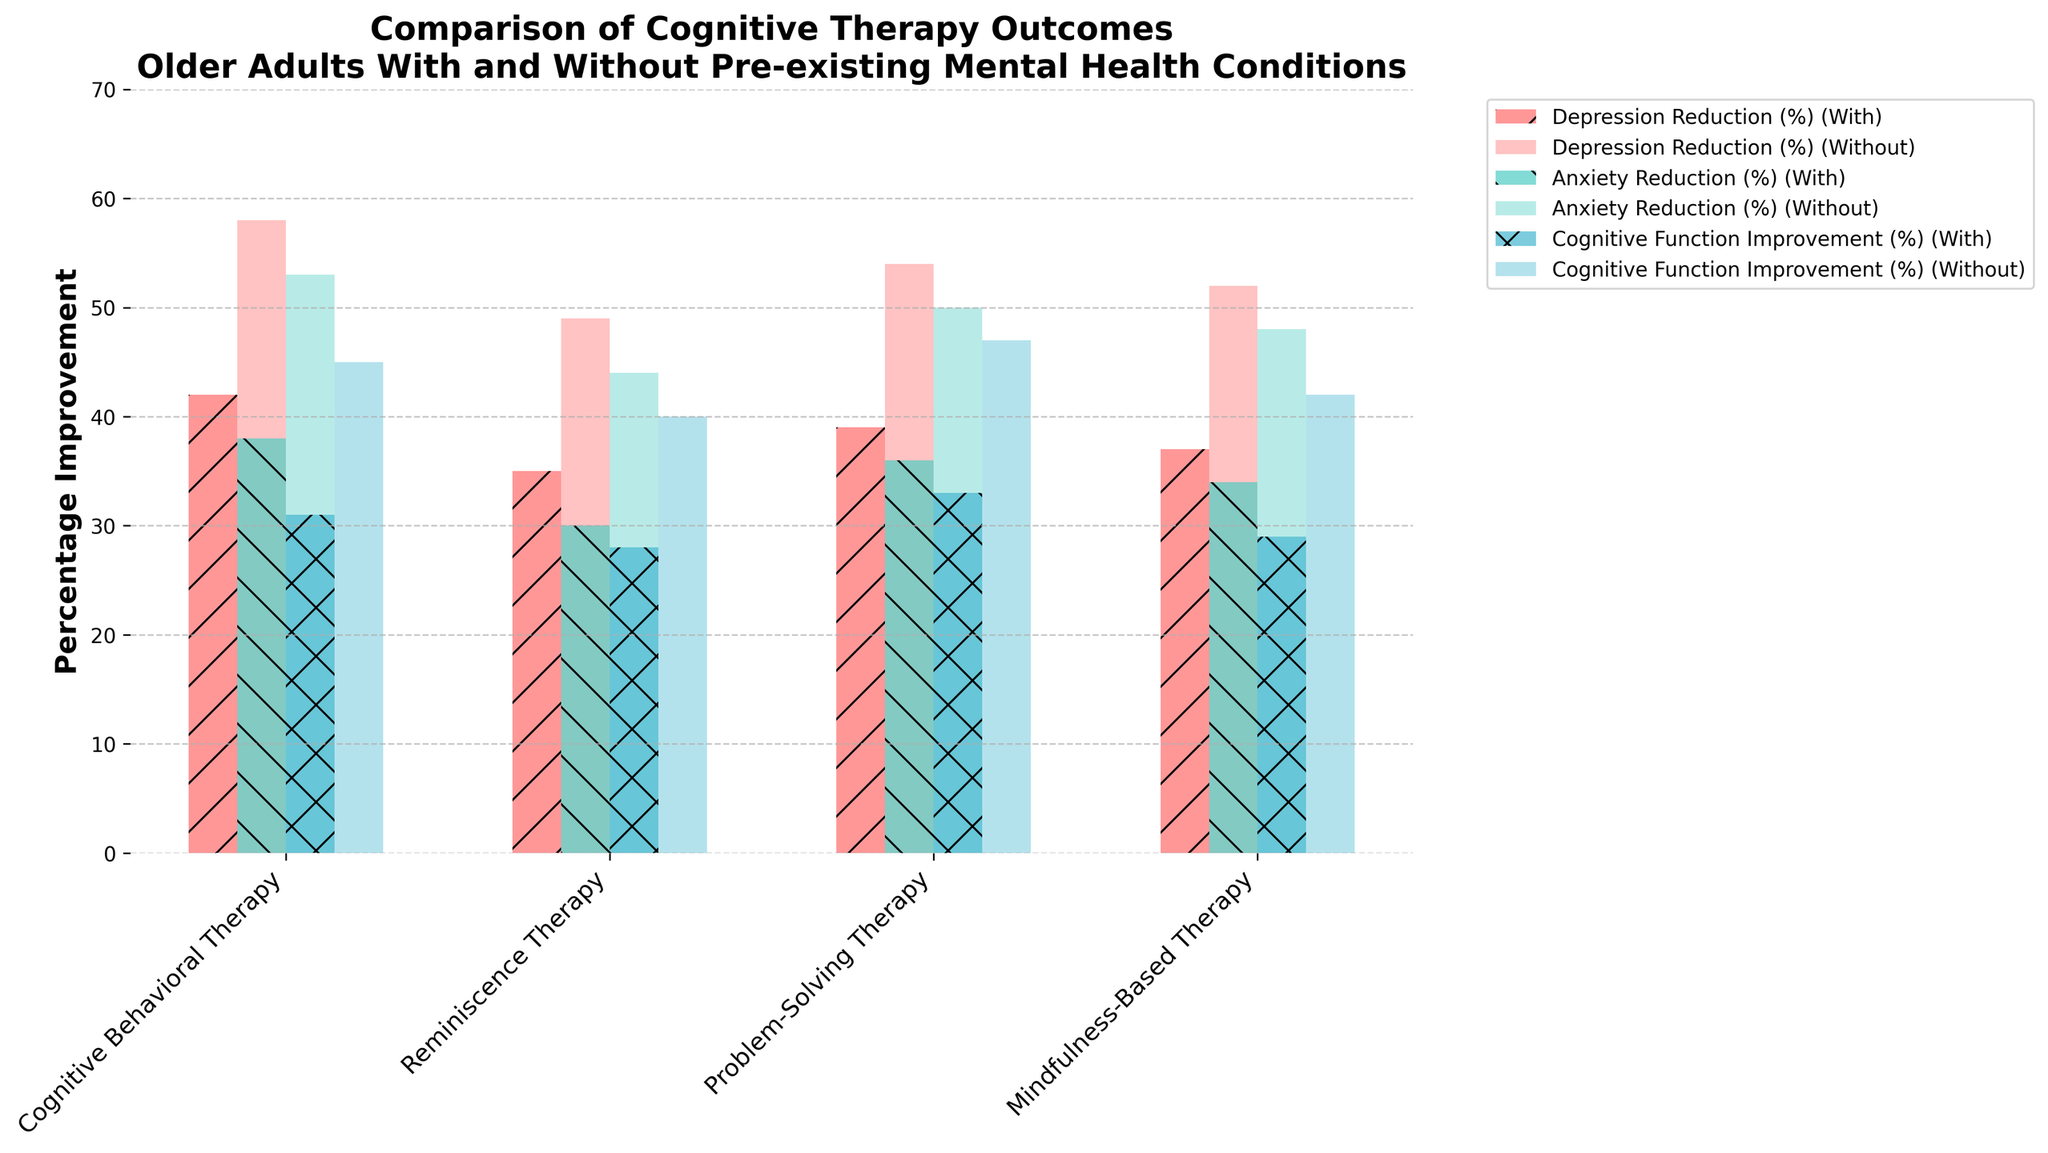What is the highest percentage improvement in depression reduction for older adults without pre-existing conditions? To find the highest percentage improvement, look at the depression reduction bars for the "Without Pre-existing Conditions" category across all therapies. The highest percentage improvement is 58% for Cognitive Behavioral Therapy.
Answer: 58% Which therapy type shows the smallest gap in anxiety reduction between older adults with and without pre-existing conditions? Compare the difference in anxiety reduction percentages between "With" and "Without" for all therapy types. For Cognitive Behavioral Therapy, the difference is 53% - 38% = 15%. For Reminiscence Therapy, it is 44% - 30% = 14%. For Problem-Solving Therapy, it is 50% - 36% = 14%. For Mindfulness-Based Therapy, it is 48% - 34% = 14%. Therefore, Reminiscence Therapy, Problem-Solving Therapy, and Mindfulness-Based Therapy show the smallest gap of 14%.
Answer: Reminiscence Therapy, Problem-Solving Therapy, and Mindfulness-Based Therapy What is the average cognitive function improvement percentage for all therapies for older adults without pre-existing conditions? Calculate the average by summing the cognitive function improvement percentages for "Without" across all therapies and then dividing by the number of therapies: (45 + 40 + 47 + 42) / 4 = 43.5%
Answer: 43.5% Which therapy type has the largest improvement in cognitive function for older adults with pre-existing conditions? Compare the cognitive function improvement percentages for "With" across all therapies. The largest improvement is 33% for Problem-Solving Therapy.
Answer: Problem-Solving Therapy Is the improvement in anxiety reduction generally higher for older adults without pre-existing conditions compared to those with pre-existing conditions? Compare the anxiety reduction percentages for "Without" and "With" across all therapies. For Cognitive Behavioral Therapy, 53% > 38%. For Reminiscence Therapy, 44% > 30%. For Problem-Solving Therapy, 50% > 36%. For Mindfulness-Based Therapy, 48% > 34%. In all cases, the "Without" category has higher percentages.
Answer: Yes What is the difference in depression reduction for Reminiscence Therapy between older adults with and without pre-existing conditions? Calculate the difference by subtracting the percentage for "With" from the percentage for "Without": 49% - 35% = 14%
Answer: 14% Which therapy type shows the most significant difference in percentage improvement of cognitive function between the two groups of older adults? Compare the differences in percentage improvement of cognitive function between "With" and "Without" for each therapy. Cognitive Behavioral Therapy: 45% - 31% = 14%, Reminiscence Therapy: 40% - 28% = 12%, Problem-Solving Therapy: 47% - 33% = 14%, Mindfulness-Based Therapy: 42% - 29% = 13%. Cognitive Behavioral Therapy and Problem-Solving Therapy show the largest difference of 14%.
Answer: Cognitive Behavioral Therapy and Problem-Solving Therapy Which visual attributes distinguish the bars representing older adults with pre-existing conditions from those without? The bars for "With" are more opaque (70% transparency) and have hatches, while the bars for "Without" are less opaque (40% transparency) and do not have hatches.
Answer: Opacity and Hatches 